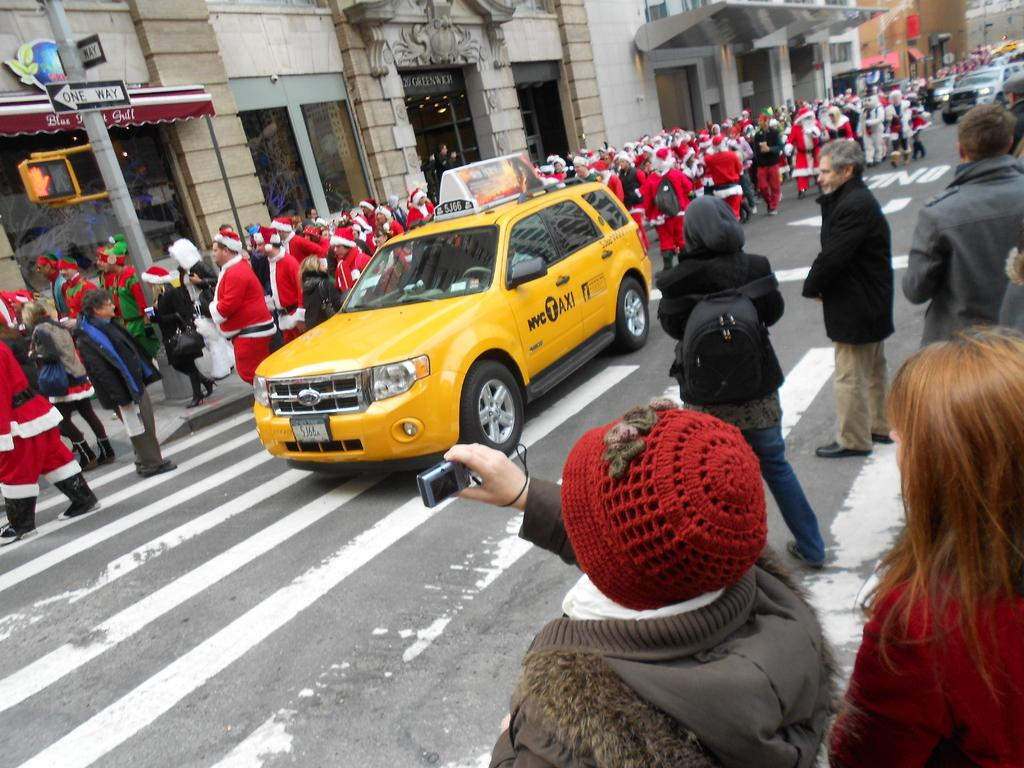<image>
Create a compact narrative representing the image presented. The yellow car in the street beside a row of people dressed as Santa, is a New York City taxi. 